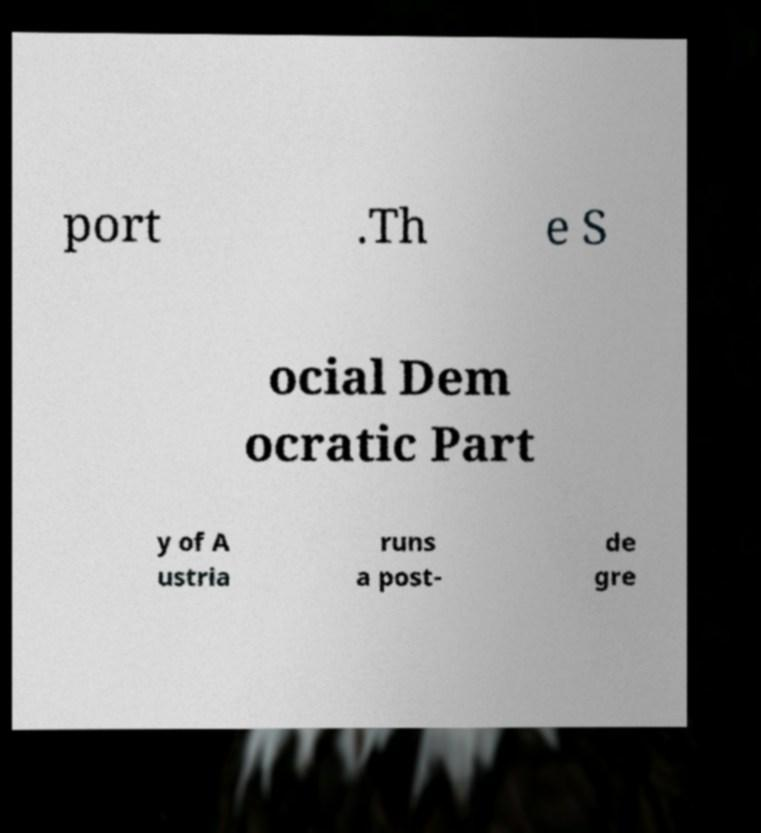Can you accurately transcribe the text from the provided image for me? port .Th e S ocial Dem ocratic Part y of A ustria runs a post- de gre 